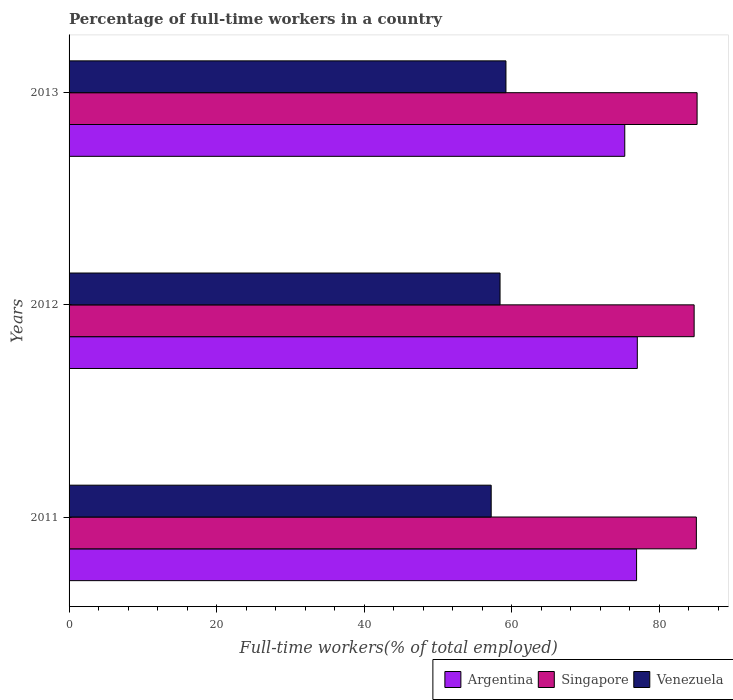How many different coloured bars are there?
Provide a succinct answer. 3. How many groups of bars are there?
Offer a very short reply. 3. How many bars are there on the 2nd tick from the bottom?
Keep it short and to the point. 3. What is the label of the 1st group of bars from the top?
Provide a succinct answer. 2013. What is the percentage of full-time workers in Argentina in 2011?
Ensure brevity in your answer.  76.9. Across all years, what is the maximum percentage of full-time workers in Singapore?
Give a very brief answer. 85.1. Across all years, what is the minimum percentage of full-time workers in Venezuela?
Provide a short and direct response. 57.2. What is the total percentage of full-time workers in Argentina in the graph?
Offer a terse response. 229.2. What is the difference between the percentage of full-time workers in Argentina in 2011 and that in 2012?
Give a very brief answer. -0.1. What is the difference between the percentage of full-time workers in Venezuela in 2013 and the percentage of full-time workers in Argentina in 2012?
Keep it short and to the point. -17.8. What is the average percentage of full-time workers in Argentina per year?
Keep it short and to the point. 76.4. In the year 2012, what is the difference between the percentage of full-time workers in Argentina and percentage of full-time workers in Venezuela?
Your response must be concise. 18.6. In how many years, is the percentage of full-time workers in Argentina greater than 8 %?
Your answer should be very brief. 3. What is the ratio of the percentage of full-time workers in Argentina in 2012 to that in 2013?
Offer a terse response. 1.02. Is the difference between the percentage of full-time workers in Argentina in 2011 and 2012 greater than the difference between the percentage of full-time workers in Venezuela in 2011 and 2012?
Offer a very short reply. Yes. What is the difference between the highest and the second highest percentage of full-time workers in Venezuela?
Provide a short and direct response. 0.8. What is the difference between the highest and the lowest percentage of full-time workers in Argentina?
Give a very brief answer. 1.7. In how many years, is the percentage of full-time workers in Argentina greater than the average percentage of full-time workers in Argentina taken over all years?
Ensure brevity in your answer.  2. Is the sum of the percentage of full-time workers in Singapore in 2012 and 2013 greater than the maximum percentage of full-time workers in Argentina across all years?
Ensure brevity in your answer.  Yes. What does the 2nd bar from the top in 2012 represents?
Your answer should be compact. Singapore. What does the 3rd bar from the bottom in 2011 represents?
Your answer should be very brief. Venezuela. Are the values on the major ticks of X-axis written in scientific E-notation?
Make the answer very short. No. What is the title of the graph?
Ensure brevity in your answer.  Percentage of full-time workers in a country. What is the label or title of the X-axis?
Give a very brief answer. Full-time workers(% of total employed). What is the Full-time workers(% of total employed) of Argentina in 2011?
Your answer should be very brief. 76.9. What is the Full-time workers(% of total employed) of Singapore in 2011?
Ensure brevity in your answer.  85. What is the Full-time workers(% of total employed) in Venezuela in 2011?
Your response must be concise. 57.2. What is the Full-time workers(% of total employed) of Argentina in 2012?
Offer a very short reply. 77. What is the Full-time workers(% of total employed) in Singapore in 2012?
Offer a very short reply. 84.7. What is the Full-time workers(% of total employed) of Venezuela in 2012?
Make the answer very short. 58.4. What is the Full-time workers(% of total employed) in Argentina in 2013?
Offer a terse response. 75.3. What is the Full-time workers(% of total employed) of Singapore in 2013?
Give a very brief answer. 85.1. What is the Full-time workers(% of total employed) in Venezuela in 2013?
Ensure brevity in your answer.  59.2. Across all years, what is the maximum Full-time workers(% of total employed) of Singapore?
Make the answer very short. 85.1. Across all years, what is the maximum Full-time workers(% of total employed) of Venezuela?
Give a very brief answer. 59.2. Across all years, what is the minimum Full-time workers(% of total employed) of Argentina?
Make the answer very short. 75.3. Across all years, what is the minimum Full-time workers(% of total employed) in Singapore?
Ensure brevity in your answer.  84.7. Across all years, what is the minimum Full-time workers(% of total employed) in Venezuela?
Offer a terse response. 57.2. What is the total Full-time workers(% of total employed) in Argentina in the graph?
Your response must be concise. 229.2. What is the total Full-time workers(% of total employed) in Singapore in the graph?
Make the answer very short. 254.8. What is the total Full-time workers(% of total employed) in Venezuela in the graph?
Provide a succinct answer. 174.8. What is the difference between the Full-time workers(% of total employed) of Argentina in 2011 and that in 2012?
Keep it short and to the point. -0.1. What is the difference between the Full-time workers(% of total employed) in Singapore in 2011 and that in 2012?
Make the answer very short. 0.3. What is the difference between the Full-time workers(% of total employed) in Venezuela in 2011 and that in 2012?
Provide a short and direct response. -1.2. What is the difference between the Full-time workers(% of total employed) in Argentina in 2011 and that in 2013?
Your answer should be compact. 1.6. What is the difference between the Full-time workers(% of total employed) in Singapore in 2012 and that in 2013?
Offer a very short reply. -0.4. What is the difference between the Full-time workers(% of total employed) in Venezuela in 2012 and that in 2013?
Ensure brevity in your answer.  -0.8. What is the difference between the Full-time workers(% of total employed) in Singapore in 2011 and the Full-time workers(% of total employed) in Venezuela in 2012?
Provide a short and direct response. 26.6. What is the difference between the Full-time workers(% of total employed) in Singapore in 2011 and the Full-time workers(% of total employed) in Venezuela in 2013?
Make the answer very short. 25.8. What is the difference between the Full-time workers(% of total employed) of Argentina in 2012 and the Full-time workers(% of total employed) of Venezuela in 2013?
Your response must be concise. 17.8. What is the difference between the Full-time workers(% of total employed) of Singapore in 2012 and the Full-time workers(% of total employed) of Venezuela in 2013?
Provide a succinct answer. 25.5. What is the average Full-time workers(% of total employed) of Argentina per year?
Your response must be concise. 76.4. What is the average Full-time workers(% of total employed) of Singapore per year?
Make the answer very short. 84.93. What is the average Full-time workers(% of total employed) in Venezuela per year?
Keep it short and to the point. 58.27. In the year 2011, what is the difference between the Full-time workers(% of total employed) of Singapore and Full-time workers(% of total employed) of Venezuela?
Offer a very short reply. 27.8. In the year 2012, what is the difference between the Full-time workers(% of total employed) of Argentina and Full-time workers(% of total employed) of Venezuela?
Your answer should be very brief. 18.6. In the year 2012, what is the difference between the Full-time workers(% of total employed) in Singapore and Full-time workers(% of total employed) in Venezuela?
Provide a succinct answer. 26.3. In the year 2013, what is the difference between the Full-time workers(% of total employed) of Argentina and Full-time workers(% of total employed) of Venezuela?
Provide a succinct answer. 16.1. In the year 2013, what is the difference between the Full-time workers(% of total employed) of Singapore and Full-time workers(% of total employed) of Venezuela?
Ensure brevity in your answer.  25.9. What is the ratio of the Full-time workers(% of total employed) in Argentina in 2011 to that in 2012?
Your response must be concise. 1. What is the ratio of the Full-time workers(% of total employed) of Venezuela in 2011 to that in 2012?
Ensure brevity in your answer.  0.98. What is the ratio of the Full-time workers(% of total employed) of Argentina in 2011 to that in 2013?
Your answer should be compact. 1.02. What is the ratio of the Full-time workers(% of total employed) of Singapore in 2011 to that in 2013?
Provide a succinct answer. 1. What is the ratio of the Full-time workers(% of total employed) of Venezuela in 2011 to that in 2013?
Ensure brevity in your answer.  0.97. What is the ratio of the Full-time workers(% of total employed) of Argentina in 2012 to that in 2013?
Make the answer very short. 1.02. What is the ratio of the Full-time workers(% of total employed) of Venezuela in 2012 to that in 2013?
Your answer should be very brief. 0.99. What is the difference between the highest and the second highest Full-time workers(% of total employed) in Argentina?
Ensure brevity in your answer.  0.1. What is the difference between the highest and the second highest Full-time workers(% of total employed) of Singapore?
Your answer should be very brief. 0.1. What is the difference between the highest and the second highest Full-time workers(% of total employed) of Venezuela?
Ensure brevity in your answer.  0.8. What is the difference between the highest and the lowest Full-time workers(% of total employed) in Argentina?
Provide a short and direct response. 1.7. What is the difference between the highest and the lowest Full-time workers(% of total employed) in Singapore?
Offer a terse response. 0.4. 